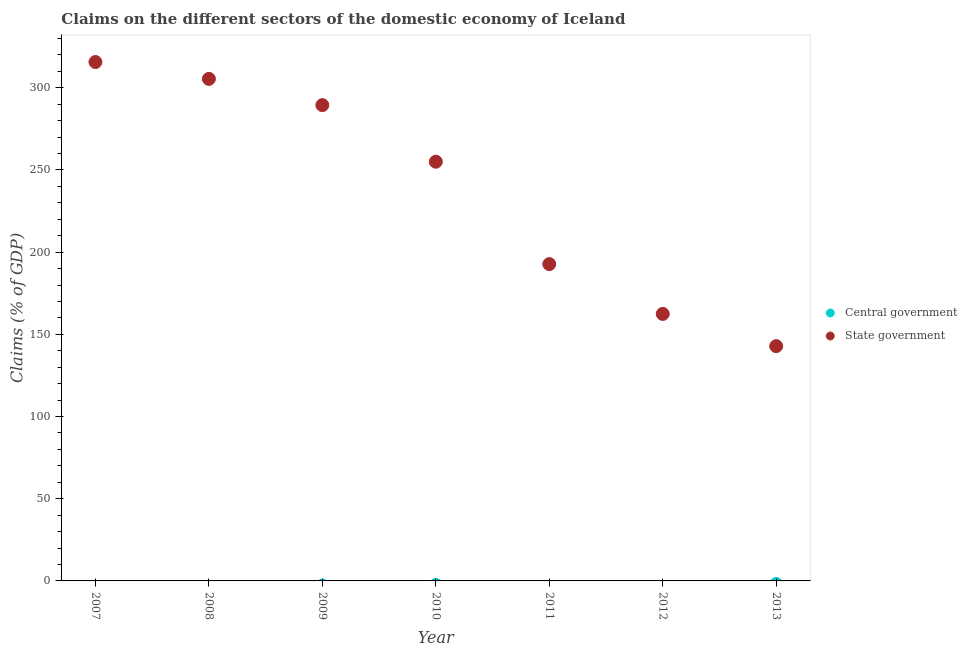How many different coloured dotlines are there?
Ensure brevity in your answer.  1. Is the number of dotlines equal to the number of legend labels?
Keep it short and to the point. No. Across all years, what is the maximum claims on state government?
Give a very brief answer. 315.68. Across all years, what is the minimum claims on central government?
Give a very brief answer. 0. In which year was the claims on state government maximum?
Provide a succinct answer. 2007. What is the difference between the claims on state government in 2009 and that in 2013?
Offer a terse response. 146.63. What is the difference between the claims on state government in 2007 and the claims on central government in 2013?
Offer a very short reply. 315.68. In how many years, is the claims on state government greater than 30 %?
Keep it short and to the point. 7. What is the ratio of the claims on state government in 2008 to that in 2013?
Your answer should be compact. 2.14. Is the claims on state government in 2008 less than that in 2013?
Your response must be concise. No. What is the difference between the highest and the second highest claims on state government?
Offer a very short reply. 10.26. What is the difference between the highest and the lowest claims on state government?
Make the answer very short. 172.85. In how many years, is the claims on state government greater than the average claims on state government taken over all years?
Your answer should be very brief. 4. Is the sum of the claims on state government in 2009 and 2013 greater than the maximum claims on central government across all years?
Provide a short and direct response. Yes. Is the claims on state government strictly less than the claims on central government over the years?
Offer a very short reply. No. How many dotlines are there?
Your response must be concise. 1. How many years are there in the graph?
Ensure brevity in your answer.  7. Are the values on the major ticks of Y-axis written in scientific E-notation?
Your response must be concise. No. Does the graph contain any zero values?
Your answer should be very brief. Yes. How are the legend labels stacked?
Your response must be concise. Vertical. What is the title of the graph?
Provide a short and direct response. Claims on the different sectors of the domestic economy of Iceland. What is the label or title of the Y-axis?
Your answer should be compact. Claims (% of GDP). What is the Claims (% of GDP) of State government in 2007?
Provide a succinct answer. 315.68. What is the Claims (% of GDP) of Central government in 2008?
Your answer should be very brief. 0. What is the Claims (% of GDP) of State government in 2008?
Your response must be concise. 305.42. What is the Claims (% of GDP) of State government in 2009?
Your answer should be very brief. 289.45. What is the Claims (% of GDP) of Central government in 2010?
Provide a succinct answer. 0. What is the Claims (% of GDP) in State government in 2010?
Ensure brevity in your answer.  255.03. What is the Claims (% of GDP) in State government in 2011?
Keep it short and to the point. 192.73. What is the Claims (% of GDP) of State government in 2012?
Offer a terse response. 162.43. What is the Claims (% of GDP) of State government in 2013?
Offer a very short reply. 142.83. Across all years, what is the maximum Claims (% of GDP) of State government?
Provide a short and direct response. 315.68. Across all years, what is the minimum Claims (% of GDP) of State government?
Your response must be concise. 142.83. What is the total Claims (% of GDP) in Central government in the graph?
Ensure brevity in your answer.  0. What is the total Claims (% of GDP) in State government in the graph?
Ensure brevity in your answer.  1663.56. What is the difference between the Claims (% of GDP) of State government in 2007 and that in 2008?
Keep it short and to the point. 10.26. What is the difference between the Claims (% of GDP) in State government in 2007 and that in 2009?
Your answer should be very brief. 26.22. What is the difference between the Claims (% of GDP) in State government in 2007 and that in 2010?
Make the answer very short. 60.65. What is the difference between the Claims (% of GDP) of State government in 2007 and that in 2011?
Your answer should be compact. 122.94. What is the difference between the Claims (% of GDP) of State government in 2007 and that in 2012?
Make the answer very short. 153.25. What is the difference between the Claims (% of GDP) of State government in 2007 and that in 2013?
Give a very brief answer. 172.85. What is the difference between the Claims (% of GDP) of State government in 2008 and that in 2009?
Keep it short and to the point. 15.96. What is the difference between the Claims (% of GDP) in State government in 2008 and that in 2010?
Offer a very short reply. 50.39. What is the difference between the Claims (% of GDP) of State government in 2008 and that in 2011?
Your answer should be compact. 112.69. What is the difference between the Claims (% of GDP) in State government in 2008 and that in 2012?
Your response must be concise. 142.99. What is the difference between the Claims (% of GDP) of State government in 2008 and that in 2013?
Make the answer very short. 162.59. What is the difference between the Claims (% of GDP) in State government in 2009 and that in 2010?
Offer a terse response. 34.43. What is the difference between the Claims (% of GDP) of State government in 2009 and that in 2011?
Your answer should be compact. 96.72. What is the difference between the Claims (% of GDP) in State government in 2009 and that in 2012?
Offer a very short reply. 127.03. What is the difference between the Claims (% of GDP) in State government in 2009 and that in 2013?
Give a very brief answer. 146.63. What is the difference between the Claims (% of GDP) of State government in 2010 and that in 2011?
Make the answer very short. 62.29. What is the difference between the Claims (% of GDP) in State government in 2010 and that in 2012?
Ensure brevity in your answer.  92.6. What is the difference between the Claims (% of GDP) of State government in 2010 and that in 2013?
Your answer should be very brief. 112.2. What is the difference between the Claims (% of GDP) of State government in 2011 and that in 2012?
Give a very brief answer. 30.31. What is the difference between the Claims (% of GDP) in State government in 2011 and that in 2013?
Offer a very short reply. 49.91. What is the difference between the Claims (% of GDP) in State government in 2012 and that in 2013?
Offer a terse response. 19.6. What is the average Claims (% of GDP) of Central government per year?
Provide a short and direct response. 0. What is the average Claims (% of GDP) of State government per year?
Keep it short and to the point. 237.65. What is the ratio of the Claims (% of GDP) of State government in 2007 to that in 2008?
Your answer should be compact. 1.03. What is the ratio of the Claims (% of GDP) in State government in 2007 to that in 2009?
Give a very brief answer. 1.09. What is the ratio of the Claims (% of GDP) of State government in 2007 to that in 2010?
Ensure brevity in your answer.  1.24. What is the ratio of the Claims (% of GDP) in State government in 2007 to that in 2011?
Your response must be concise. 1.64. What is the ratio of the Claims (% of GDP) in State government in 2007 to that in 2012?
Ensure brevity in your answer.  1.94. What is the ratio of the Claims (% of GDP) of State government in 2007 to that in 2013?
Your answer should be compact. 2.21. What is the ratio of the Claims (% of GDP) of State government in 2008 to that in 2009?
Provide a succinct answer. 1.06. What is the ratio of the Claims (% of GDP) of State government in 2008 to that in 2010?
Your response must be concise. 1.2. What is the ratio of the Claims (% of GDP) of State government in 2008 to that in 2011?
Provide a succinct answer. 1.58. What is the ratio of the Claims (% of GDP) in State government in 2008 to that in 2012?
Provide a succinct answer. 1.88. What is the ratio of the Claims (% of GDP) in State government in 2008 to that in 2013?
Your answer should be compact. 2.14. What is the ratio of the Claims (% of GDP) of State government in 2009 to that in 2010?
Your answer should be very brief. 1.14. What is the ratio of the Claims (% of GDP) of State government in 2009 to that in 2011?
Offer a very short reply. 1.5. What is the ratio of the Claims (% of GDP) of State government in 2009 to that in 2012?
Offer a very short reply. 1.78. What is the ratio of the Claims (% of GDP) in State government in 2009 to that in 2013?
Provide a short and direct response. 2.03. What is the ratio of the Claims (% of GDP) of State government in 2010 to that in 2011?
Your answer should be very brief. 1.32. What is the ratio of the Claims (% of GDP) of State government in 2010 to that in 2012?
Keep it short and to the point. 1.57. What is the ratio of the Claims (% of GDP) in State government in 2010 to that in 2013?
Provide a short and direct response. 1.79. What is the ratio of the Claims (% of GDP) in State government in 2011 to that in 2012?
Your answer should be compact. 1.19. What is the ratio of the Claims (% of GDP) in State government in 2011 to that in 2013?
Your response must be concise. 1.35. What is the ratio of the Claims (% of GDP) in State government in 2012 to that in 2013?
Keep it short and to the point. 1.14. What is the difference between the highest and the second highest Claims (% of GDP) of State government?
Your response must be concise. 10.26. What is the difference between the highest and the lowest Claims (% of GDP) in State government?
Your response must be concise. 172.85. 